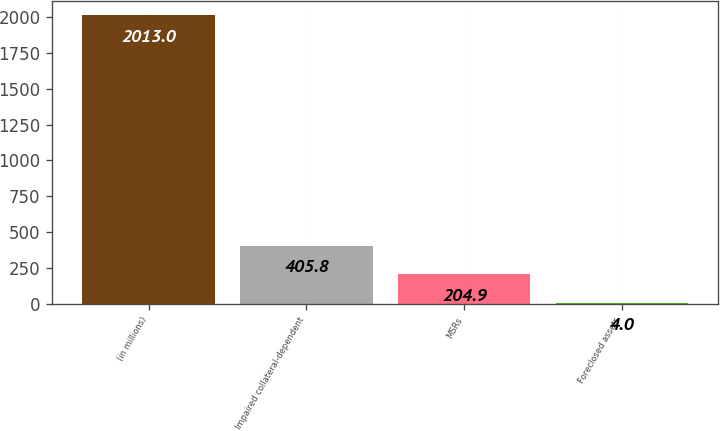Convert chart to OTSL. <chart><loc_0><loc_0><loc_500><loc_500><bar_chart><fcel>(in millions)<fcel>Impaired collateral-dependent<fcel>MSRs<fcel>Foreclosed assets<nl><fcel>2013<fcel>405.8<fcel>204.9<fcel>4<nl></chart> 